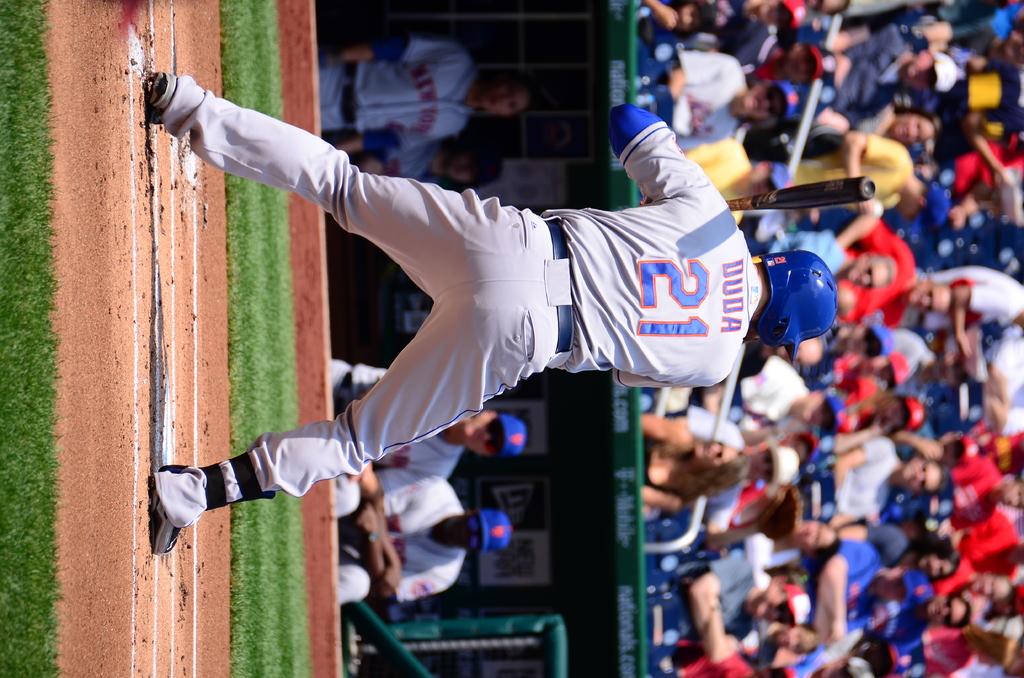What is the name above 21?
Your answer should be compact. Duda. 